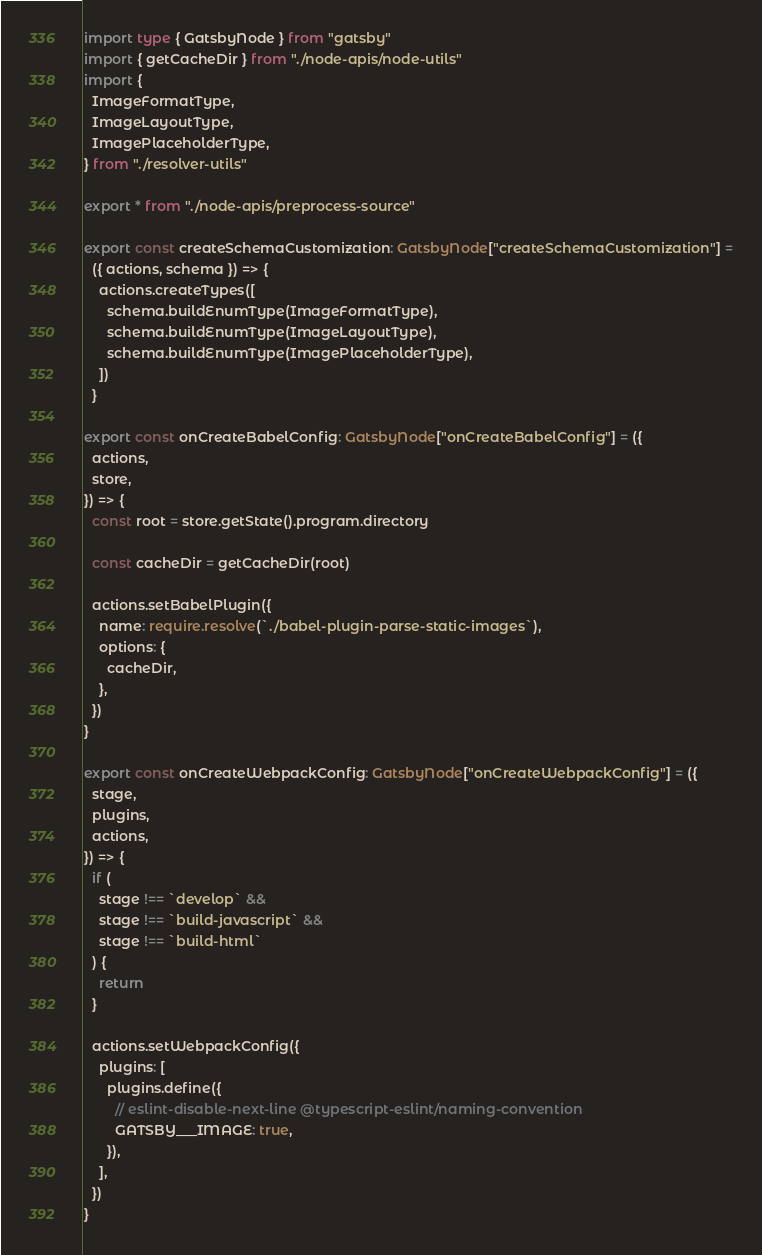<code> <loc_0><loc_0><loc_500><loc_500><_TypeScript_>import type { GatsbyNode } from "gatsby"
import { getCacheDir } from "./node-apis/node-utils"
import {
  ImageFormatType,
  ImageLayoutType,
  ImagePlaceholderType,
} from "./resolver-utils"

export * from "./node-apis/preprocess-source"

export const createSchemaCustomization: GatsbyNode["createSchemaCustomization"] =
  ({ actions, schema }) => {
    actions.createTypes([
      schema.buildEnumType(ImageFormatType),
      schema.buildEnumType(ImageLayoutType),
      schema.buildEnumType(ImagePlaceholderType),
    ])
  }

export const onCreateBabelConfig: GatsbyNode["onCreateBabelConfig"] = ({
  actions,
  store,
}) => {
  const root = store.getState().program.directory

  const cacheDir = getCacheDir(root)

  actions.setBabelPlugin({
    name: require.resolve(`./babel-plugin-parse-static-images`),
    options: {
      cacheDir,
    },
  })
}

export const onCreateWebpackConfig: GatsbyNode["onCreateWebpackConfig"] = ({
  stage,
  plugins,
  actions,
}) => {
  if (
    stage !== `develop` &&
    stage !== `build-javascript` &&
    stage !== `build-html`
  ) {
    return
  }

  actions.setWebpackConfig({
    plugins: [
      plugins.define({
        // eslint-disable-next-line @typescript-eslint/naming-convention
        GATSBY___IMAGE: true,
      }),
    ],
  })
}
</code> 